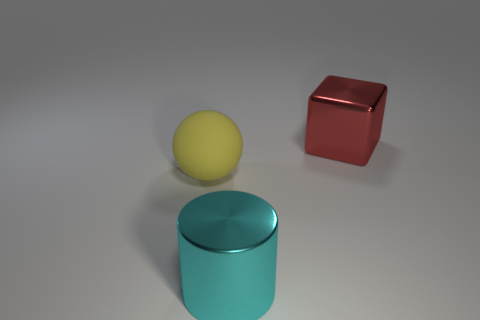There is a large thing that is behind the large yellow matte ball; what shape is it?
Your response must be concise. Cube. How many large rubber things are right of the large metallic block behind the big metal thing on the left side of the large red metal block?
Your response must be concise. 0. There is a yellow object; is it the same size as the metal object that is behind the big yellow ball?
Provide a succinct answer. Yes. How many other balls have the same material as the large yellow ball?
Ensure brevity in your answer.  0. Are any large cyan cylinders visible?
Give a very brief answer. Yes. There is a shiny object in front of the ball; how big is it?
Your response must be concise. Large. How many blocks are big cyan metallic objects or yellow matte objects?
Offer a very short reply. 0. The big object that is to the right of the big matte sphere and behind the cyan cylinder has what shape?
Offer a terse response. Cube. Is there a red object that has the same size as the sphere?
Offer a terse response. Yes. What number of things are objects that are to the right of the big yellow object or rubber objects?
Offer a terse response. 3. 